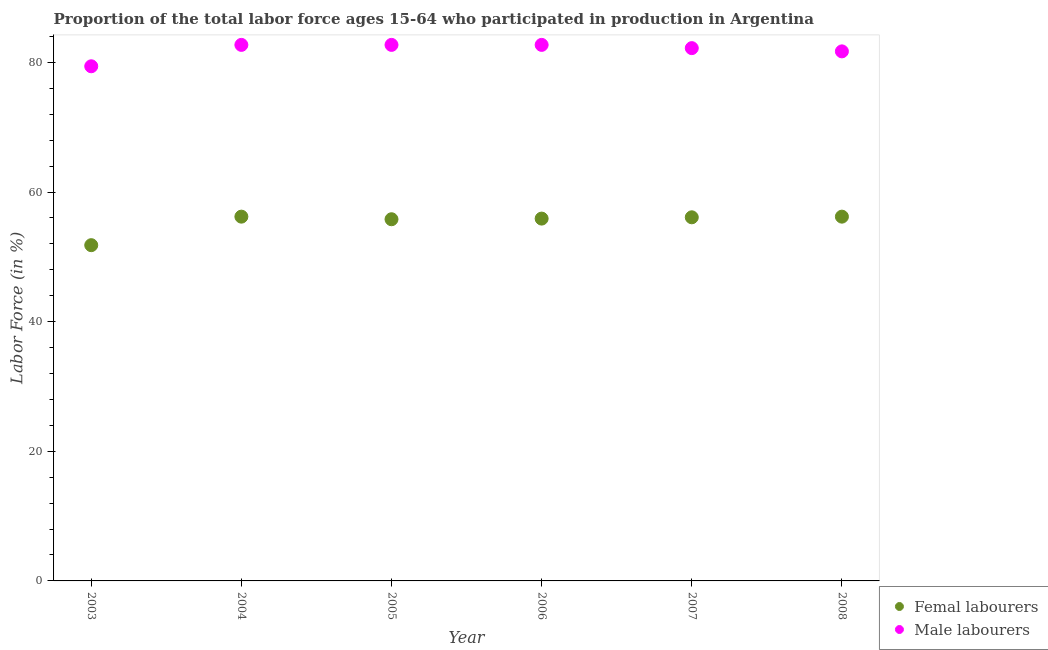What is the percentage of female labor force in 2008?
Keep it short and to the point. 56.2. Across all years, what is the maximum percentage of male labour force?
Your answer should be compact. 82.7. Across all years, what is the minimum percentage of male labour force?
Make the answer very short. 79.4. In which year was the percentage of male labour force minimum?
Ensure brevity in your answer.  2003. What is the total percentage of male labour force in the graph?
Make the answer very short. 491.4. What is the difference between the percentage of male labour force in 2007 and that in 2008?
Offer a terse response. 0.5. What is the difference between the percentage of male labour force in 2003 and the percentage of female labor force in 2004?
Your answer should be compact. 23.2. What is the average percentage of male labour force per year?
Provide a short and direct response. 81.9. In the year 2008, what is the difference between the percentage of female labor force and percentage of male labour force?
Keep it short and to the point. -25.5. In how many years, is the percentage of male labour force greater than 68 %?
Make the answer very short. 6. What is the ratio of the percentage of male labour force in 2003 to that in 2007?
Make the answer very short. 0.97. Is the difference between the percentage of male labour force in 2003 and 2005 greater than the difference between the percentage of female labor force in 2003 and 2005?
Ensure brevity in your answer.  Yes. What is the difference between the highest and the lowest percentage of female labor force?
Offer a very short reply. 4.4. Does the percentage of male labour force monotonically increase over the years?
Provide a short and direct response. No. Is the percentage of male labour force strictly greater than the percentage of female labor force over the years?
Your answer should be very brief. Yes. Is the percentage of male labour force strictly less than the percentage of female labor force over the years?
Your answer should be compact. No. How many dotlines are there?
Ensure brevity in your answer.  2. What is the difference between two consecutive major ticks on the Y-axis?
Ensure brevity in your answer.  20. Does the graph contain any zero values?
Make the answer very short. No. Does the graph contain grids?
Your response must be concise. No. How many legend labels are there?
Give a very brief answer. 2. How are the legend labels stacked?
Provide a succinct answer. Vertical. What is the title of the graph?
Your answer should be very brief. Proportion of the total labor force ages 15-64 who participated in production in Argentina. What is the label or title of the X-axis?
Offer a terse response. Year. What is the label or title of the Y-axis?
Keep it short and to the point. Labor Force (in %). What is the Labor Force (in %) in Femal labourers in 2003?
Provide a succinct answer. 51.8. What is the Labor Force (in %) in Male labourers in 2003?
Your answer should be very brief. 79.4. What is the Labor Force (in %) in Femal labourers in 2004?
Make the answer very short. 56.2. What is the Labor Force (in %) of Male labourers in 2004?
Ensure brevity in your answer.  82.7. What is the Labor Force (in %) in Femal labourers in 2005?
Your response must be concise. 55.8. What is the Labor Force (in %) in Male labourers in 2005?
Make the answer very short. 82.7. What is the Labor Force (in %) of Femal labourers in 2006?
Give a very brief answer. 55.9. What is the Labor Force (in %) in Male labourers in 2006?
Make the answer very short. 82.7. What is the Labor Force (in %) of Femal labourers in 2007?
Your response must be concise. 56.1. What is the Labor Force (in %) in Male labourers in 2007?
Offer a terse response. 82.2. What is the Labor Force (in %) of Femal labourers in 2008?
Provide a short and direct response. 56.2. What is the Labor Force (in %) in Male labourers in 2008?
Your answer should be very brief. 81.7. Across all years, what is the maximum Labor Force (in %) in Femal labourers?
Your response must be concise. 56.2. Across all years, what is the maximum Labor Force (in %) of Male labourers?
Offer a very short reply. 82.7. Across all years, what is the minimum Labor Force (in %) in Femal labourers?
Your response must be concise. 51.8. Across all years, what is the minimum Labor Force (in %) of Male labourers?
Keep it short and to the point. 79.4. What is the total Labor Force (in %) in Femal labourers in the graph?
Offer a very short reply. 332. What is the total Labor Force (in %) in Male labourers in the graph?
Make the answer very short. 491.4. What is the difference between the Labor Force (in %) of Femal labourers in 2003 and that in 2004?
Provide a short and direct response. -4.4. What is the difference between the Labor Force (in %) of Femal labourers in 2003 and that in 2005?
Offer a terse response. -4. What is the difference between the Labor Force (in %) in Male labourers in 2003 and that in 2005?
Your answer should be compact. -3.3. What is the difference between the Labor Force (in %) in Femal labourers in 2003 and that in 2006?
Your response must be concise. -4.1. What is the difference between the Labor Force (in %) of Femal labourers in 2003 and that in 2007?
Provide a short and direct response. -4.3. What is the difference between the Labor Force (in %) of Male labourers in 2003 and that in 2008?
Ensure brevity in your answer.  -2.3. What is the difference between the Labor Force (in %) of Femal labourers in 2004 and that in 2005?
Provide a short and direct response. 0.4. What is the difference between the Labor Force (in %) of Male labourers in 2004 and that in 2005?
Your response must be concise. 0. What is the difference between the Labor Force (in %) of Femal labourers in 2005 and that in 2006?
Your response must be concise. -0.1. What is the difference between the Labor Force (in %) in Male labourers in 2005 and that in 2007?
Make the answer very short. 0.5. What is the difference between the Labor Force (in %) of Femal labourers in 2005 and that in 2008?
Keep it short and to the point. -0.4. What is the difference between the Labor Force (in %) in Femal labourers in 2006 and that in 2007?
Make the answer very short. -0.2. What is the difference between the Labor Force (in %) in Femal labourers in 2007 and that in 2008?
Make the answer very short. -0.1. What is the difference between the Labor Force (in %) in Male labourers in 2007 and that in 2008?
Make the answer very short. 0.5. What is the difference between the Labor Force (in %) in Femal labourers in 2003 and the Labor Force (in %) in Male labourers in 2004?
Your answer should be very brief. -30.9. What is the difference between the Labor Force (in %) in Femal labourers in 2003 and the Labor Force (in %) in Male labourers in 2005?
Ensure brevity in your answer.  -30.9. What is the difference between the Labor Force (in %) of Femal labourers in 2003 and the Labor Force (in %) of Male labourers in 2006?
Your response must be concise. -30.9. What is the difference between the Labor Force (in %) of Femal labourers in 2003 and the Labor Force (in %) of Male labourers in 2007?
Your answer should be compact. -30.4. What is the difference between the Labor Force (in %) in Femal labourers in 2003 and the Labor Force (in %) in Male labourers in 2008?
Offer a very short reply. -29.9. What is the difference between the Labor Force (in %) in Femal labourers in 2004 and the Labor Force (in %) in Male labourers in 2005?
Your response must be concise. -26.5. What is the difference between the Labor Force (in %) in Femal labourers in 2004 and the Labor Force (in %) in Male labourers in 2006?
Your answer should be very brief. -26.5. What is the difference between the Labor Force (in %) in Femal labourers in 2004 and the Labor Force (in %) in Male labourers in 2008?
Keep it short and to the point. -25.5. What is the difference between the Labor Force (in %) of Femal labourers in 2005 and the Labor Force (in %) of Male labourers in 2006?
Ensure brevity in your answer.  -26.9. What is the difference between the Labor Force (in %) of Femal labourers in 2005 and the Labor Force (in %) of Male labourers in 2007?
Offer a terse response. -26.4. What is the difference between the Labor Force (in %) in Femal labourers in 2005 and the Labor Force (in %) in Male labourers in 2008?
Keep it short and to the point. -25.9. What is the difference between the Labor Force (in %) in Femal labourers in 2006 and the Labor Force (in %) in Male labourers in 2007?
Make the answer very short. -26.3. What is the difference between the Labor Force (in %) in Femal labourers in 2006 and the Labor Force (in %) in Male labourers in 2008?
Provide a succinct answer. -25.8. What is the difference between the Labor Force (in %) of Femal labourers in 2007 and the Labor Force (in %) of Male labourers in 2008?
Provide a short and direct response. -25.6. What is the average Labor Force (in %) in Femal labourers per year?
Give a very brief answer. 55.33. What is the average Labor Force (in %) in Male labourers per year?
Your answer should be very brief. 81.9. In the year 2003, what is the difference between the Labor Force (in %) in Femal labourers and Labor Force (in %) in Male labourers?
Keep it short and to the point. -27.6. In the year 2004, what is the difference between the Labor Force (in %) in Femal labourers and Labor Force (in %) in Male labourers?
Your response must be concise. -26.5. In the year 2005, what is the difference between the Labor Force (in %) in Femal labourers and Labor Force (in %) in Male labourers?
Offer a very short reply. -26.9. In the year 2006, what is the difference between the Labor Force (in %) in Femal labourers and Labor Force (in %) in Male labourers?
Offer a very short reply. -26.8. In the year 2007, what is the difference between the Labor Force (in %) in Femal labourers and Labor Force (in %) in Male labourers?
Your response must be concise. -26.1. In the year 2008, what is the difference between the Labor Force (in %) in Femal labourers and Labor Force (in %) in Male labourers?
Give a very brief answer. -25.5. What is the ratio of the Labor Force (in %) of Femal labourers in 2003 to that in 2004?
Keep it short and to the point. 0.92. What is the ratio of the Labor Force (in %) of Male labourers in 2003 to that in 2004?
Provide a short and direct response. 0.96. What is the ratio of the Labor Force (in %) of Femal labourers in 2003 to that in 2005?
Your answer should be compact. 0.93. What is the ratio of the Labor Force (in %) of Male labourers in 2003 to that in 2005?
Keep it short and to the point. 0.96. What is the ratio of the Labor Force (in %) in Femal labourers in 2003 to that in 2006?
Provide a short and direct response. 0.93. What is the ratio of the Labor Force (in %) of Male labourers in 2003 to that in 2006?
Offer a terse response. 0.96. What is the ratio of the Labor Force (in %) in Femal labourers in 2003 to that in 2007?
Offer a terse response. 0.92. What is the ratio of the Labor Force (in %) of Male labourers in 2003 to that in 2007?
Your answer should be compact. 0.97. What is the ratio of the Labor Force (in %) of Femal labourers in 2003 to that in 2008?
Offer a terse response. 0.92. What is the ratio of the Labor Force (in %) in Male labourers in 2003 to that in 2008?
Your response must be concise. 0.97. What is the ratio of the Labor Force (in %) of Femal labourers in 2004 to that in 2005?
Keep it short and to the point. 1.01. What is the ratio of the Labor Force (in %) in Femal labourers in 2004 to that in 2006?
Provide a short and direct response. 1.01. What is the ratio of the Labor Force (in %) in Femal labourers in 2004 to that in 2007?
Offer a terse response. 1. What is the ratio of the Labor Force (in %) of Male labourers in 2004 to that in 2007?
Offer a very short reply. 1.01. What is the ratio of the Labor Force (in %) of Male labourers in 2004 to that in 2008?
Keep it short and to the point. 1.01. What is the ratio of the Labor Force (in %) of Male labourers in 2005 to that in 2006?
Your answer should be very brief. 1. What is the ratio of the Labor Force (in %) in Femal labourers in 2005 to that in 2007?
Give a very brief answer. 0.99. What is the ratio of the Labor Force (in %) of Male labourers in 2005 to that in 2008?
Keep it short and to the point. 1.01. What is the ratio of the Labor Force (in %) in Femal labourers in 2006 to that in 2007?
Keep it short and to the point. 1. What is the ratio of the Labor Force (in %) of Femal labourers in 2006 to that in 2008?
Make the answer very short. 0.99. What is the ratio of the Labor Force (in %) in Male labourers in 2006 to that in 2008?
Your answer should be very brief. 1.01. What is the ratio of the Labor Force (in %) in Male labourers in 2007 to that in 2008?
Give a very brief answer. 1.01. What is the difference between the highest and the second highest Labor Force (in %) of Femal labourers?
Offer a very short reply. 0. What is the difference between the highest and the lowest Labor Force (in %) of Male labourers?
Offer a terse response. 3.3. 